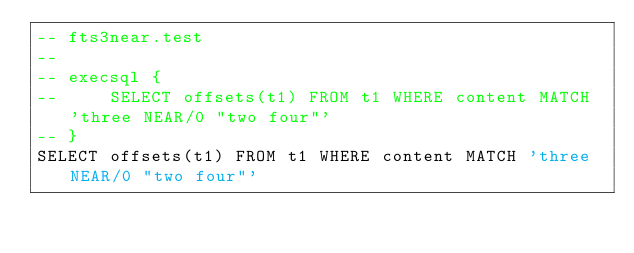<code> <loc_0><loc_0><loc_500><loc_500><_SQL_>-- fts3near.test
-- 
-- execsql {
--     SELECT offsets(t1) FROM t1 WHERE content MATCH 'three NEAR/0 "two four"'
-- }
SELECT offsets(t1) FROM t1 WHERE content MATCH 'three NEAR/0 "two four"'</code> 